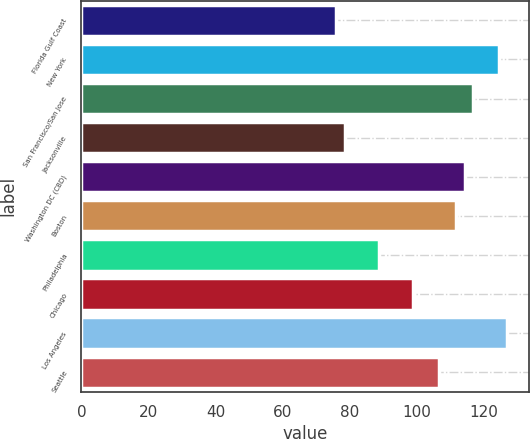Convert chart. <chart><loc_0><loc_0><loc_500><loc_500><bar_chart><fcel>Florida Gulf Coast<fcel>New York<fcel>San Francisco/San Jose<fcel>Jacksonville<fcel>Washington DC (CBD)<fcel>Boston<fcel>Philadelphia<fcel>Chicago<fcel>Los Angeles<fcel>Seattle<nl><fcel>75.98<fcel>124.62<fcel>116.94<fcel>78.54<fcel>114.38<fcel>111.82<fcel>88.78<fcel>99.02<fcel>127.18<fcel>106.7<nl></chart> 